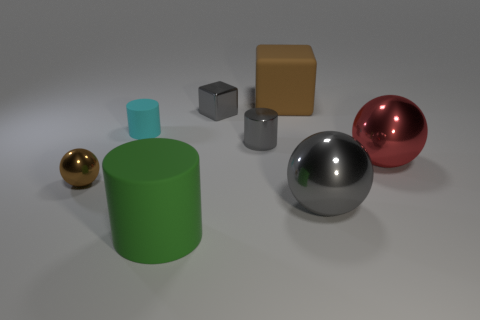Is there another metallic cylinder of the same size as the gray shiny cylinder?
Keep it short and to the point. No. What number of things are tiny things in front of the red metallic sphere or objects that are on the right side of the tiny metallic cylinder?
Ensure brevity in your answer.  4. There is a rubber cylinder behind the red metal sphere in front of the gray metallic cube; what color is it?
Make the answer very short. Cyan. What color is the tiny sphere that is the same material as the tiny gray cylinder?
Your answer should be very brief. Brown. How many tiny spheres have the same color as the small shiny cube?
Provide a succinct answer. 0. How many objects are gray cylinders or big metal spheres?
Your answer should be compact. 3. There is a cyan matte object that is the same size as the brown metal sphere; what is its shape?
Keep it short and to the point. Cylinder. How many matte objects are both to the right of the big cylinder and to the left of the brown matte cube?
Your answer should be compact. 0. What material is the big sphere that is in front of the red sphere?
Offer a terse response. Metal. What size is the cyan thing that is the same material as the brown block?
Give a very brief answer. Small. 